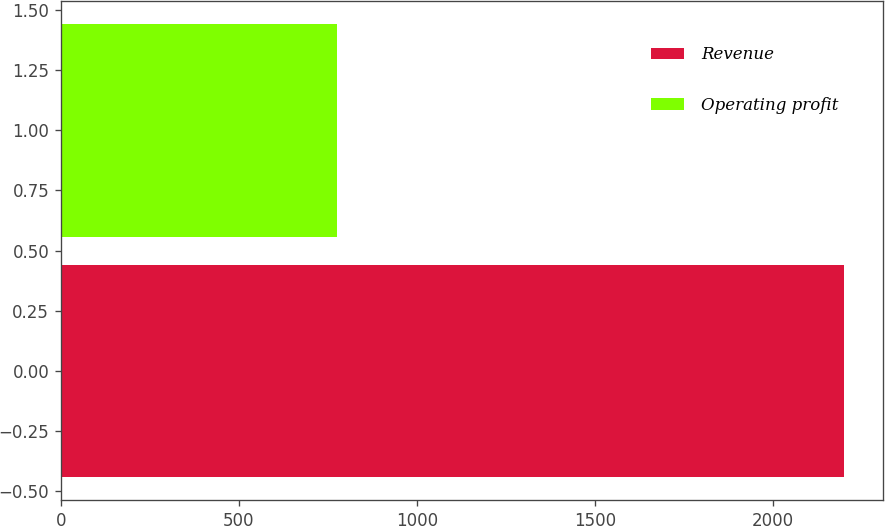Convert chart to OTSL. <chart><loc_0><loc_0><loc_500><loc_500><bar_chart><fcel>Revenue<fcel>Operating profit<nl><fcel>2201<fcel>777<nl></chart> 